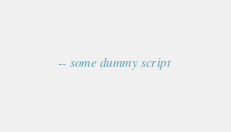Convert code to text. <code><loc_0><loc_0><loc_500><loc_500><_SQL_>-- some dummy script
</code> 